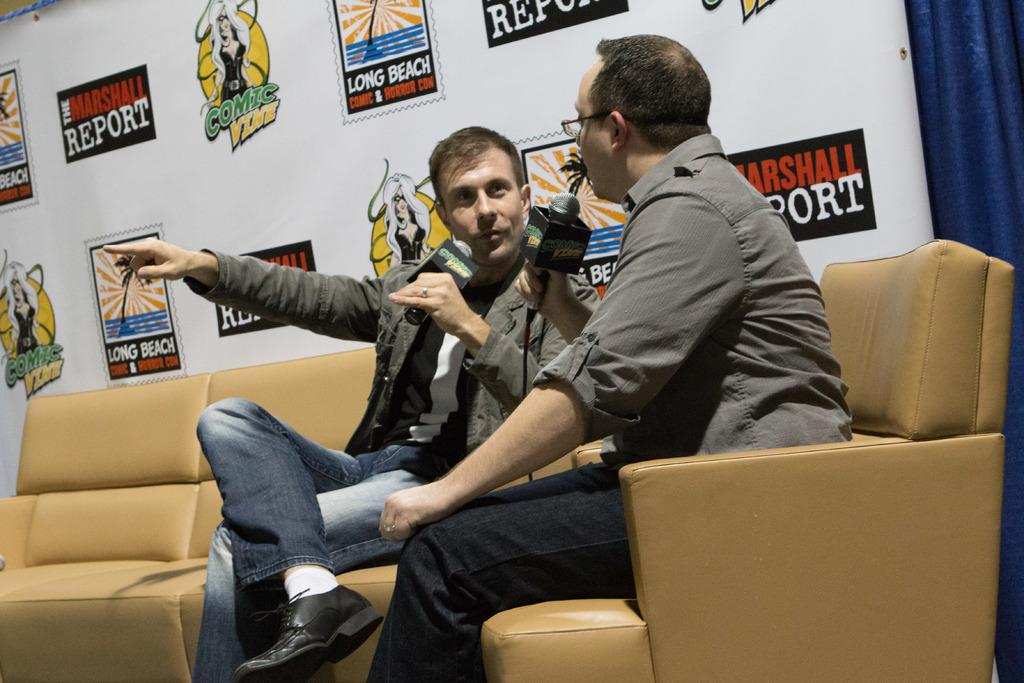How many people are in the image? There are two persons in the image. What are the persons doing in the image? The persons are sitting on a sofa and speaking in front of a mic. What are the persons holding in their hands? The persons are holding a mic in their hands. What can be seen in the background of the image? There is a banner visible in the image. What type of owl can be seen perched on the structure in the image? There is no owl or structure present in the image. How many cattle are visible in the image? There are no cattle present in the image. 